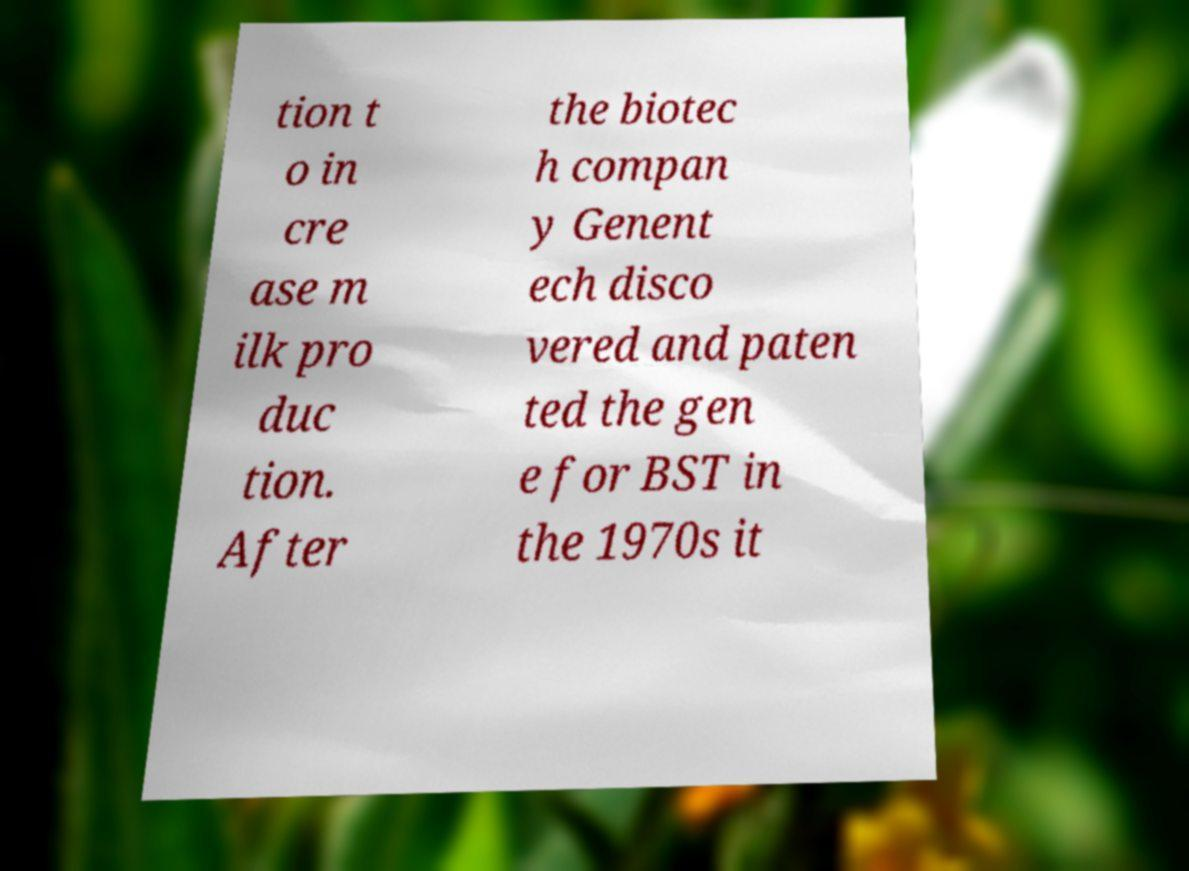What messages or text are displayed in this image? I need them in a readable, typed format. tion t o in cre ase m ilk pro duc tion. After the biotec h compan y Genent ech disco vered and paten ted the gen e for BST in the 1970s it 